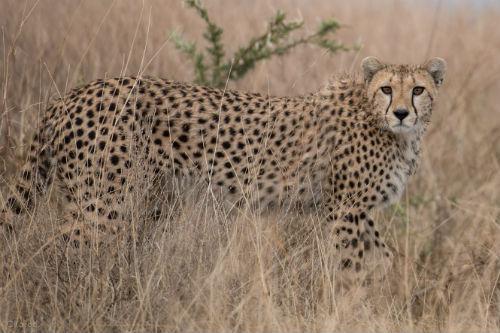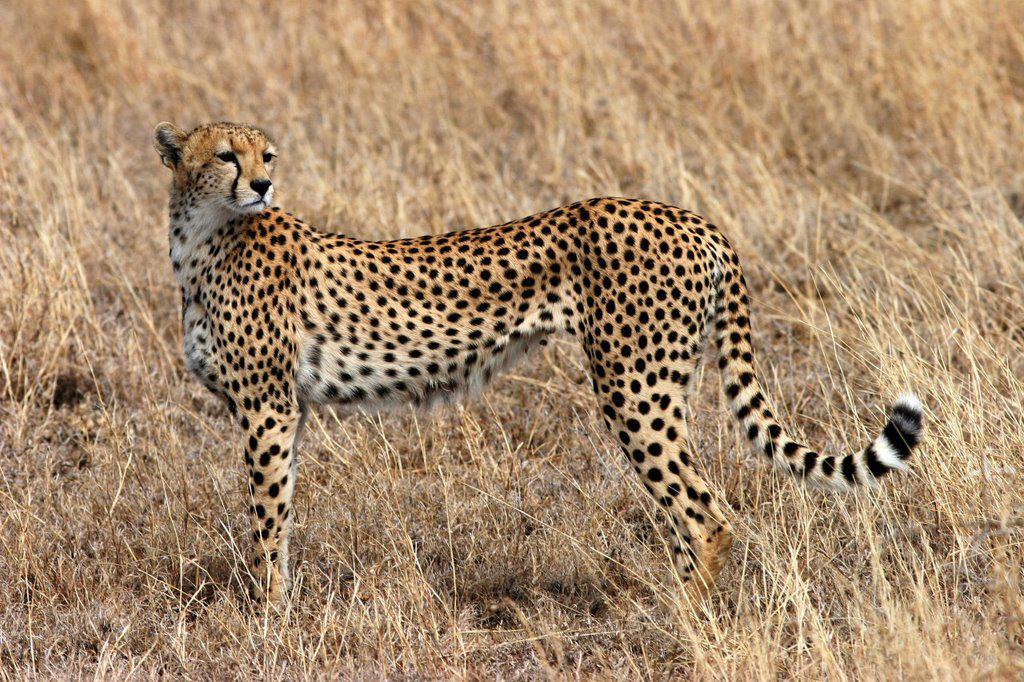The first image is the image on the left, the second image is the image on the right. Analyze the images presented: Is the assertion "There are at least 3 cheetahs in each image." valid? Answer yes or no. No. 